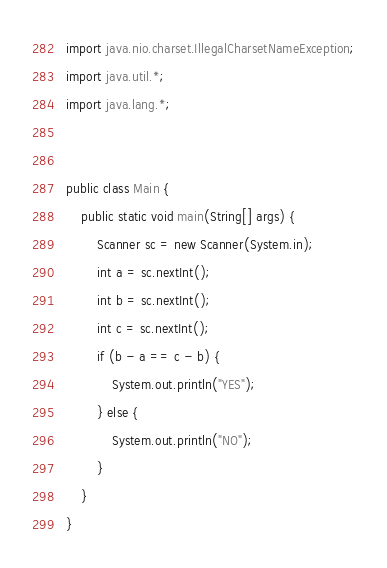<code> <loc_0><loc_0><loc_500><loc_500><_Java_>import java.nio.charset.IllegalCharsetNameException;
import java.util.*;
import java.lang.*;


public class Main {
	public static void main(String[] args) {
		Scanner sc = new Scanner(System.in);
		int a = sc.nextInt();
		int b = sc.nextInt();
		int c = sc.nextInt();
		if (b - a == c - b) {
			System.out.println("YES");
		} else {
			System.out.println("NO");
		}
	}
}</code> 